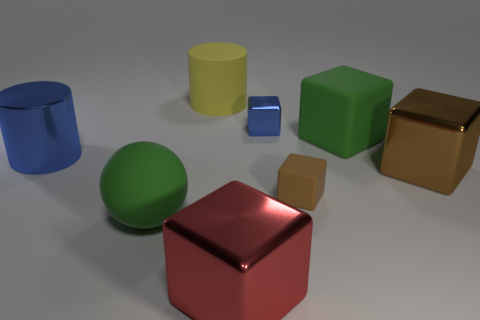Subtract all red metal blocks. How many blocks are left? 4 Add 2 big brown metallic objects. How many objects exist? 10 Subtract all blue blocks. How many blocks are left? 4 Subtract 1 spheres. How many spheres are left? 0 Subtract all tiny shiny blocks. Subtract all blue shiny blocks. How many objects are left? 6 Add 4 blue things. How many blue things are left? 6 Add 6 small things. How many small things exist? 8 Subtract 0 green cylinders. How many objects are left? 8 Subtract all spheres. How many objects are left? 7 Subtract all gray blocks. Subtract all green cylinders. How many blocks are left? 5 